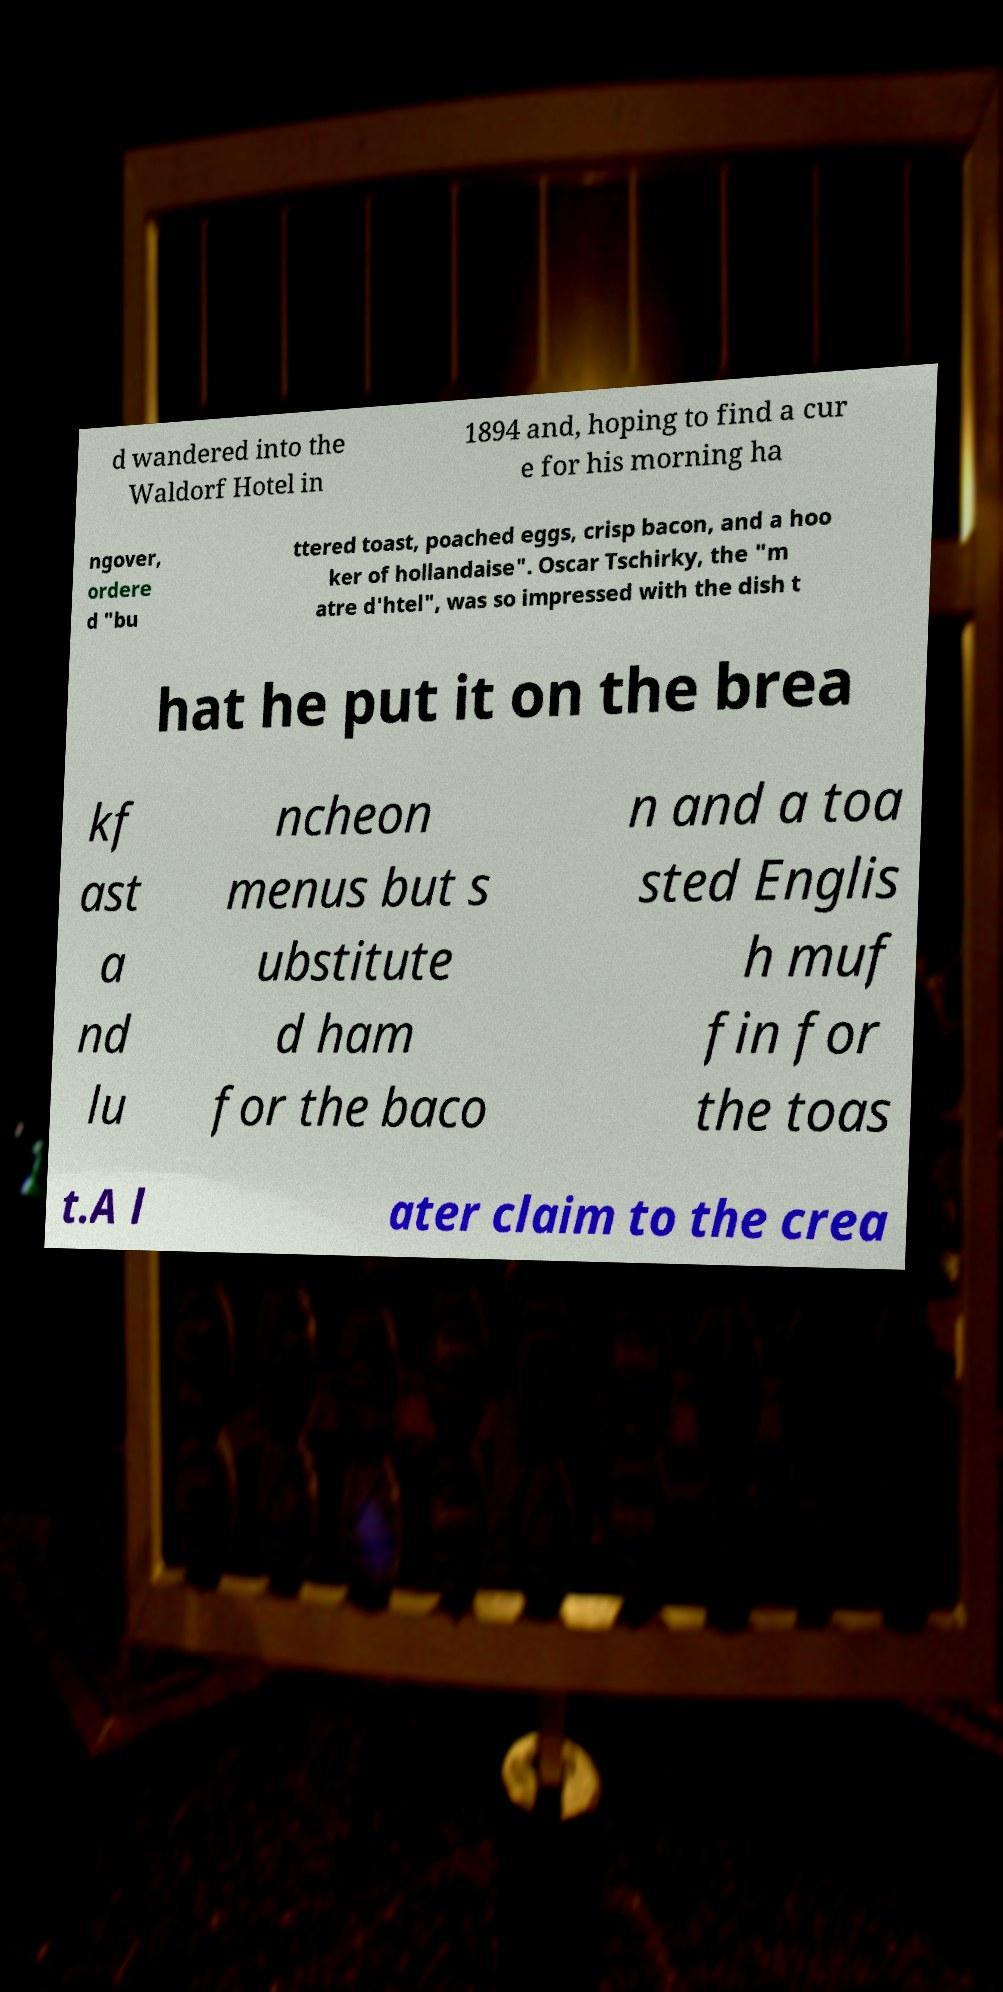Can you accurately transcribe the text from the provided image for me? d wandered into the Waldorf Hotel in 1894 and, hoping to find a cur e for his morning ha ngover, ordere d "bu ttered toast, poached eggs, crisp bacon, and a hoo ker of hollandaise". Oscar Tschirky, the "m atre d'htel", was so impressed with the dish t hat he put it on the brea kf ast a nd lu ncheon menus but s ubstitute d ham for the baco n and a toa sted Englis h muf fin for the toas t.A l ater claim to the crea 